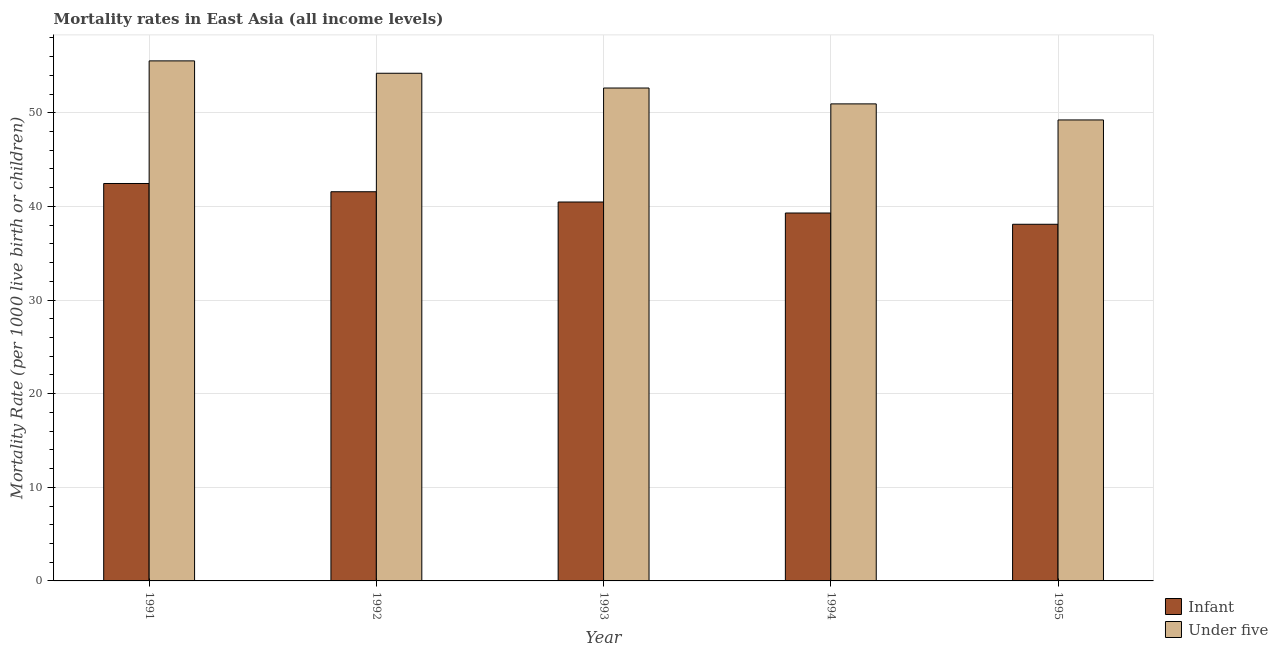How many different coloured bars are there?
Make the answer very short. 2. Are the number of bars on each tick of the X-axis equal?
Provide a short and direct response. Yes. How many bars are there on the 3rd tick from the left?
Your answer should be compact. 2. How many bars are there on the 1st tick from the right?
Your answer should be very brief. 2. What is the under-5 mortality rate in 1992?
Your response must be concise. 54.22. Across all years, what is the maximum infant mortality rate?
Offer a terse response. 42.45. Across all years, what is the minimum infant mortality rate?
Give a very brief answer. 38.09. In which year was the under-5 mortality rate minimum?
Make the answer very short. 1995. What is the total infant mortality rate in the graph?
Offer a very short reply. 201.87. What is the difference between the infant mortality rate in 1993 and that in 1994?
Your response must be concise. 1.17. What is the difference between the under-5 mortality rate in 1993 and the infant mortality rate in 1995?
Give a very brief answer. 3.41. What is the average under-5 mortality rate per year?
Ensure brevity in your answer.  52.52. In the year 1994, what is the difference between the under-5 mortality rate and infant mortality rate?
Provide a succinct answer. 0. In how many years, is the infant mortality rate greater than 18?
Provide a short and direct response. 5. What is the ratio of the infant mortality rate in 1993 to that in 1995?
Ensure brevity in your answer.  1.06. Is the difference between the under-5 mortality rate in 1992 and 1993 greater than the difference between the infant mortality rate in 1992 and 1993?
Ensure brevity in your answer.  No. What is the difference between the highest and the second highest infant mortality rate?
Offer a very short reply. 0.88. What is the difference between the highest and the lowest under-5 mortality rate?
Provide a short and direct response. 6.31. Is the sum of the infant mortality rate in 1991 and 1995 greater than the maximum under-5 mortality rate across all years?
Make the answer very short. Yes. What does the 2nd bar from the left in 1993 represents?
Provide a succinct answer. Under five. What does the 2nd bar from the right in 1991 represents?
Offer a very short reply. Infant. How many years are there in the graph?
Offer a very short reply. 5. What is the difference between two consecutive major ticks on the Y-axis?
Give a very brief answer. 10. Where does the legend appear in the graph?
Offer a terse response. Bottom right. How many legend labels are there?
Offer a very short reply. 2. How are the legend labels stacked?
Offer a terse response. Vertical. What is the title of the graph?
Offer a terse response. Mortality rates in East Asia (all income levels). What is the label or title of the Y-axis?
Provide a short and direct response. Mortality Rate (per 1000 live birth or children). What is the Mortality Rate (per 1000 live birth or children) in Infant in 1991?
Your answer should be very brief. 42.45. What is the Mortality Rate (per 1000 live birth or children) of Under five in 1991?
Keep it short and to the point. 55.54. What is the Mortality Rate (per 1000 live birth or children) in Infant in 1992?
Offer a very short reply. 41.57. What is the Mortality Rate (per 1000 live birth or children) of Under five in 1992?
Provide a short and direct response. 54.22. What is the Mortality Rate (per 1000 live birth or children) of Infant in 1993?
Provide a succinct answer. 40.47. What is the Mortality Rate (per 1000 live birth or children) of Under five in 1993?
Your answer should be compact. 52.64. What is the Mortality Rate (per 1000 live birth or children) in Infant in 1994?
Your answer should be compact. 39.3. What is the Mortality Rate (per 1000 live birth or children) in Under five in 1994?
Keep it short and to the point. 50.95. What is the Mortality Rate (per 1000 live birth or children) of Infant in 1995?
Your response must be concise. 38.09. What is the Mortality Rate (per 1000 live birth or children) of Under five in 1995?
Offer a terse response. 49.24. Across all years, what is the maximum Mortality Rate (per 1000 live birth or children) of Infant?
Give a very brief answer. 42.45. Across all years, what is the maximum Mortality Rate (per 1000 live birth or children) in Under five?
Keep it short and to the point. 55.54. Across all years, what is the minimum Mortality Rate (per 1000 live birth or children) of Infant?
Offer a very short reply. 38.09. Across all years, what is the minimum Mortality Rate (per 1000 live birth or children) in Under five?
Your answer should be very brief. 49.24. What is the total Mortality Rate (per 1000 live birth or children) in Infant in the graph?
Offer a terse response. 201.87. What is the total Mortality Rate (per 1000 live birth or children) of Under five in the graph?
Offer a terse response. 262.6. What is the difference between the Mortality Rate (per 1000 live birth or children) in Infant in 1991 and that in 1992?
Offer a very short reply. 0.88. What is the difference between the Mortality Rate (per 1000 live birth or children) of Under five in 1991 and that in 1992?
Ensure brevity in your answer.  1.32. What is the difference between the Mortality Rate (per 1000 live birth or children) in Infant in 1991 and that in 1993?
Give a very brief answer. 1.98. What is the difference between the Mortality Rate (per 1000 live birth or children) of Under five in 1991 and that in 1993?
Ensure brevity in your answer.  2.9. What is the difference between the Mortality Rate (per 1000 live birth or children) in Infant in 1991 and that in 1994?
Make the answer very short. 3.15. What is the difference between the Mortality Rate (per 1000 live birth or children) in Under five in 1991 and that in 1994?
Your answer should be compact. 4.59. What is the difference between the Mortality Rate (per 1000 live birth or children) of Infant in 1991 and that in 1995?
Your answer should be very brief. 4.36. What is the difference between the Mortality Rate (per 1000 live birth or children) of Under five in 1991 and that in 1995?
Provide a succinct answer. 6.31. What is the difference between the Mortality Rate (per 1000 live birth or children) of Infant in 1992 and that in 1993?
Offer a terse response. 1.1. What is the difference between the Mortality Rate (per 1000 live birth or children) in Under five in 1992 and that in 1993?
Ensure brevity in your answer.  1.58. What is the difference between the Mortality Rate (per 1000 live birth or children) in Infant in 1992 and that in 1994?
Provide a succinct answer. 2.27. What is the difference between the Mortality Rate (per 1000 live birth or children) in Under five in 1992 and that in 1994?
Keep it short and to the point. 3.27. What is the difference between the Mortality Rate (per 1000 live birth or children) in Infant in 1992 and that in 1995?
Ensure brevity in your answer.  3.48. What is the difference between the Mortality Rate (per 1000 live birth or children) in Under five in 1992 and that in 1995?
Your answer should be very brief. 4.99. What is the difference between the Mortality Rate (per 1000 live birth or children) of Infant in 1993 and that in 1994?
Offer a terse response. 1.17. What is the difference between the Mortality Rate (per 1000 live birth or children) in Under five in 1993 and that in 1994?
Your answer should be very brief. 1.69. What is the difference between the Mortality Rate (per 1000 live birth or children) of Infant in 1993 and that in 1995?
Provide a short and direct response. 2.38. What is the difference between the Mortality Rate (per 1000 live birth or children) of Under five in 1993 and that in 1995?
Your response must be concise. 3.41. What is the difference between the Mortality Rate (per 1000 live birth or children) of Infant in 1994 and that in 1995?
Offer a terse response. 1.2. What is the difference between the Mortality Rate (per 1000 live birth or children) in Under five in 1994 and that in 1995?
Your answer should be compact. 1.72. What is the difference between the Mortality Rate (per 1000 live birth or children) in Infant in 1991 and the Mortality Rate (per 1000 live birth or children) in Under five in 1992?
Your response must be concise. -11.77. What is the difference between the Mortality Rate (per 1000 live birth or children) of Infant in 1991 and the Mortality Rate (per 1000 live birth or children) of Under five in 1993?
Your answer should be compact. -10.2. What is the difference between the Mortality Rate (per 1000 live birth or children) of Infant in 1991 and the Mortality Rate (per 1000 live birth or children) of Under five in 1994?
Your answer should be compact. -8.5. What is the difference between the Mortality Rate (per 1000 live birth or children) in Infant in 1991 and the Mortality Rate (per 1000 live birth or children) in Under five in 1995?
Ensure brevity in your answer.  -6.79. What is the difference between the Mortality Rate (per 1000 live birth or children) of Infant in 1992 and the Mortality Rate (per 1000 live birth or children) of Under five in 1993?
Offer a very short reply. -11.08. What is the difference between the Mortality Rate (per 1000 live birth or children) in Infant in 1992 and the Mortality Rate (per 1000 live birth or children) in Under five in 1994?
Provide a short and direct response. -9.38. What is the difference between the Mortality Rate (per 1000 live birth or children) of Infant in 1992 and the Mortality Rate (per 1000 live birth or children) of Under five in 1995?
Provide a succinct answer. -7.67. What is the difference between the Mortality Rate (per 1000 live birth or children) in Infant in 1993 and the Mortality Rate (per 1000 live birth or children) in Under five in 1994?
Offer a very short reply. -10.48. What is the difference between the Mortality Rate (per 1000 live birth or children) of Infant in 1993 and the Mortality Rate (per 1000 live birth or children) of Under five in 1995?
Your answer should be very brief. -8.76. What is the difference between the Mortality Rate (per 1000 live birth or children) of Infant in 1994 and the Mortality Rate (per 1000 live birth or children) of Under five in 1995?
Offer a terse response. -9.94. What is the average Mortality Rate (per 1000 live birth or children) of Infant per year?
Provide a succinct answer. 40.37. What is the average Mortality Rate (per 1000 live birth or children) of Under five per year?
Make the answer very short. 52.52. In the year 1991, what is the difference between the Mortality Rate (per 1000 live birth or children) in Infant and Mortality Rate (per 1000 live birth or children) in Under five?
Keep it short and to the point. -13.1. In the year 1992, what is the difference between the Mortality Rate (per 1000 live birth or children) of Infant and Mortality Rate (per 1000 live birth or children) of Under five?
Provide a short and direct response. -12.65. In the year 1993, what is the difference between the Mortality Rate (per 1000 live birth or children) of Infant and Mortality Rate (per 1000 live birth or children) of Under five?
Provide a short and direct response. -12.17. In the year 1994, what is the difference between the Mortality Rate (per 1000 live birth or children) of Infant and Mortality Rate (per 1000 live birth or children) of Under five?
Offer a terse response. -11.65. In the year 1995, what is the difference between the Mortality Rate (per 1000 live birth or children) of Infant and Mortality Rate (per 1000 live birth or children) of Under five?
Offer a terse response. -11.14. What is the ratio of the Mortality Rate (per 1000 live birth or children) of Infant in 1991 to that in 1992?
Offer a very short reply. 1.02. What is the ratio of the Mortality Rate (per 1000 live birth or children) in Under five in 1991 to that in 1992?
Make the answer very short. 1.02. What is the ratio of the Mortality Rate (per 1000 live birth or children) of Infant in 1991 to that in 1993?
Provide a short and direct response. 1.05. What is the ratio of the Mortality Rate (per 1000 live birth or children) of Under five in 1991 to that in 1993?
Your response must be concise. 1.06. What is the ratio of the Mortality Rate (per 1000 live birth or children) in Infant in 1991 to that in 1994?
Offer a terse response. 1.08. What is the ratio of the Mortality Rate (per 1000 live birth or children) in Under five in 1991 to that in 1994?
Offer a very short reply. 1.09. What is the ratio of the Mortality Rate (per 1000 live birth or children) of Infant in 1991 to that in 1995?
Make the answer very short. 1.11. What is the ratio of the Mortality Rate (per 1000 live birth or children) in Under five in 1991 to that in 1995?
Your answer should be very brief. 1.13. What is the ratio of the Mortality Rate (per 1000 live birth or children) of Infant in 1992 to that in 1993?
Provide a succinct answer. 1.03. What is the ratio of the Mortality Rate (per 1000 live birth or children) in Infant in 1992 to that in 1994?
Your answer should be very brief. 1.06. What is the ratio of the Mortality Rate (per 1000 live birth or children) in Under five in 1992 to that in 1994?
Make the answer very short. 1.06. What is the ratio of the Mortality Rate (per 1000 live birth or children) of Infant in 1992 to that in 1995?
Your answer should be compact. 1.09. What is the ratio of the Mortality Rate (per 1000 live birth or children) in Under five in 1992 to that in 1995?
Your answer should be compact. 1.1. What is the ratio of the Mortality Rate (per 1000 live birth or children) of Infant in 1993 to that in 1994?
Provide a short and direct response. 1.03. What is the ratio of the Mortality Rate (per 1000 live birth or children) in Infant in 1993 to that in 1995?
Keep it short and to the point. 1.06. What is the ratio of the Mortality Rate (per 1000 live birth or children) in Under five in 1993 to that in 1995?
Offer a very short reply. 1.07. What is the ratio of the Mortality Rate (per 1000 live birth or children) in Infant in 1994 to that in 1995?
Ensure brevity in your answer.  1.03. What is the ratio of the Mortality Rate (per 1000 live birth or children) of Under five in 1994 to that in 1995?
Ensure brevity in your answer.  1.03. What is the difference between the highest and the second highest Mortality Rate (per 1000 live birth or children) of Infant?
Offer a terse response. 0.88. What is the difference between the highest and the second highest Mortality Rate (per 1000 live birth or children) of Under five?
Provide a succinct answer. 1.32. What is the difference between the highest and the lowest Mortality Rate (per 1000 live birth or children) in Infant?
Keep it short and to the point. 4.36. What is the difference between the highest and the lowest Mortality Rate (per 1000 live birth or children) in Under five?
Ensure brevity in your answer.  6.31. 